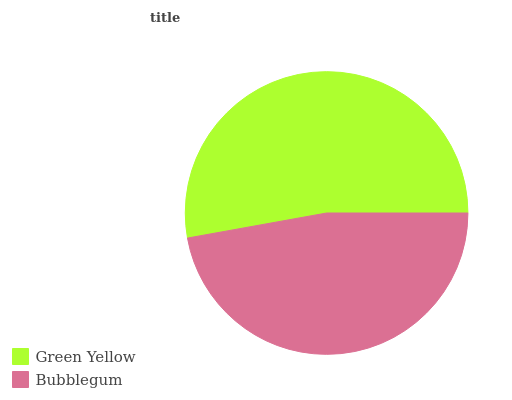Is Bubblegum the minimum?
Answer yes or no. Yes. Is Green Yellow the maximum?
Answer yes or no. Yes. Is Bubblegum the maximum?
Answer yes or no. No. Is Green Yellow greater than Bubblegum?
Answer yes or no. Yes. Is Bubblegum less than Green Yellow?
Answer yes or no. Yes. Is Bubblegum greater than Green Yellow?
Answer yes or no. No. Is Green Yellow less than Bubblegum?
Answer yes or no. No. Is Green Yellow the high median?
Answer yes or no. Yes. Is Bubblegum the low median?
Answer yes or no. Yes. Is Bubblegum the high median?
Answer yes or no. No. Is Green Yellow the low median?
Answer yes or no. No. 